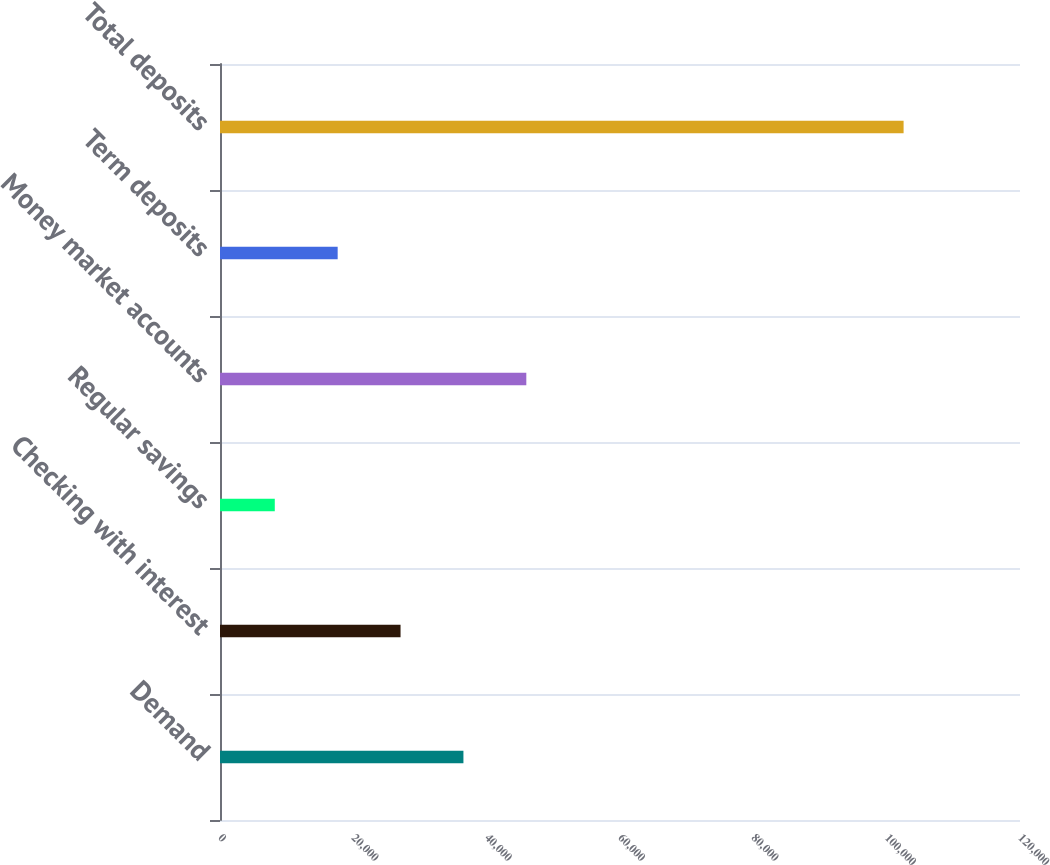Convert chart to OTSL. <chart><loc_0><loc_0><loc_500><loc_500><bar_chart><fcel>Demand<fcel>Checking with interest<fcel>Regular savings<fcel>Money market accounts<fcel>Term deposits<fcel>Total deposits<nl><fcel>36514.3<fcel>27082.2<fcel>8218<fcel>45946.4<fcel>17650.1<fcel>102539<nl></chart> 